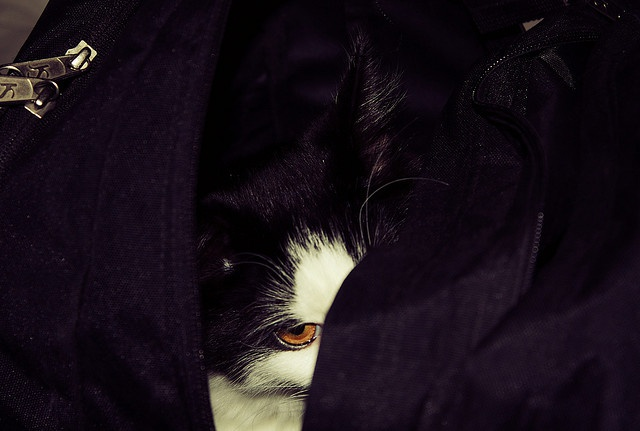Describe the objects in this image and their specific colors. I can see suitcase in black, gray, and tan tones, backpack in black, gray, and tan tones, and cat in black, tan, and beige tones in this image. 